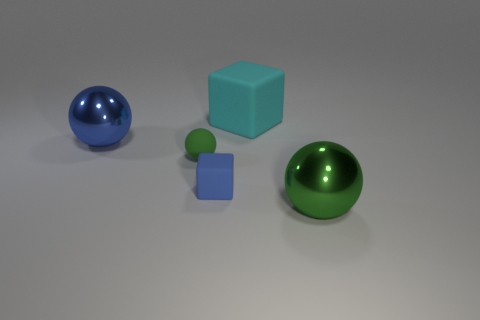What number of tiny purple matte cylinders are there?
Your answer should be very brief. 0. How many things are big shiny objects on the left side of the tiny blue object or tiny blue rubber objects?
Your answer should be compact. 2. Is the color of the cube behind the small blue object the same as the tiny matte sphere?
Ensure brevity in your answer.  No. What number of other objects are there of the same color as the matte sphere?
Your response must be concise. 1. How many tiny things are either cubes or purple cubes?
Provide a short and direct response. 1. Are there more large green shiny balls than purple matte spheres?
Make the answer very short. Yes. Is the tiny block made of the same material as the large green thing?
Your response must be concise. No. Are there any other things that have the same material as the big block?
Keep it short and to the point. Yes. Is the number of blue cubes that are in front of the tiny cube greater than the number of tiny objects?
Your answer should be very brief. No. Is the color of the small matte block the same as the large cube?
Provide a succinct answer. No. 